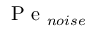Convert formula to latex. <formula><loc_0><loc_0><loc_500><loc_500>P e _ { n o i s e }</formula> 